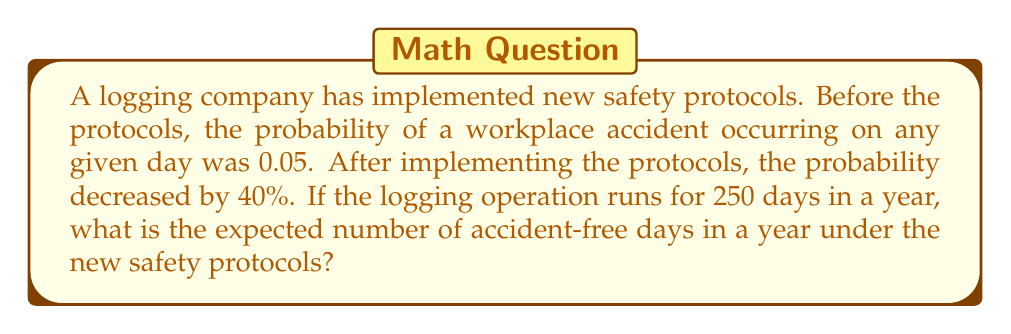Help me with this question. Let's approach this problem step-by-step:

1) First, we need to calculate the new probability of an accident occurring after the safety protocols were implemented:

   Original probability: $p_{original} = 0.05$
   Decrease: 40% = 0.4
   
   New probability: $p_{new} = p_{original} \cdot (1 - 0.4) = 0.05 \cdot 0.6 = 0.03$

2) The probability of an accident-free day is the complement of the probability of an accident occurring:

   $p_{accident-free} = 1 - p_{new} = 1 - 0.03 = 0.97$

3) Now, we need to calculate the expected number of accident-free days in a year. In probability theory, the expected value of a binomial distribution is given by $n \cdot p$, where $n$ is the number of trials and $p$ is the probability of success on each trial.

   In this case:
   $n = 250$ (number of working days in a year)
   $p = 0.97$ (probability of an accident-free day)

   Expected number of accident-free days = $250 \cdot 0.97 = 242.5$

4) Since we can't have a fractional number of days, we round to the nearest whole number.
Answer: The expected number of accident-free days in a year under the new safety protocols is 243 days. 